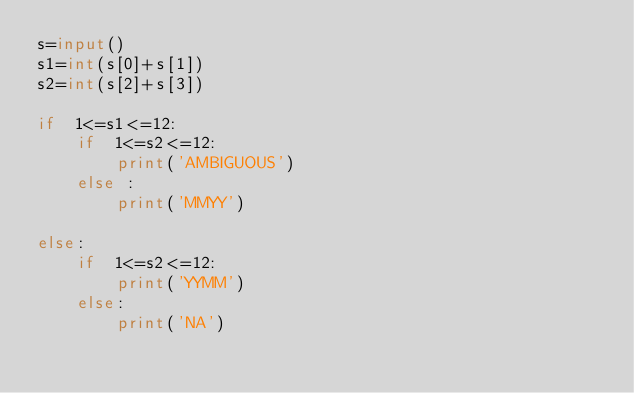Convert code to text. <code><loc_0><loc_0><loc_500><loc_500><_Python_>s=input()
s1=int(s[0]+s[1])
s2=int(s[2]+s[3])

if  1<=s1<=12:
    if  1<=s2<=12:
        print('AMBIGUOUS')
    else :
        print('MMYY')

else:
    if  1<=s2<=12:
        print('YYMM')
    else:
        print('NA')
</code> 